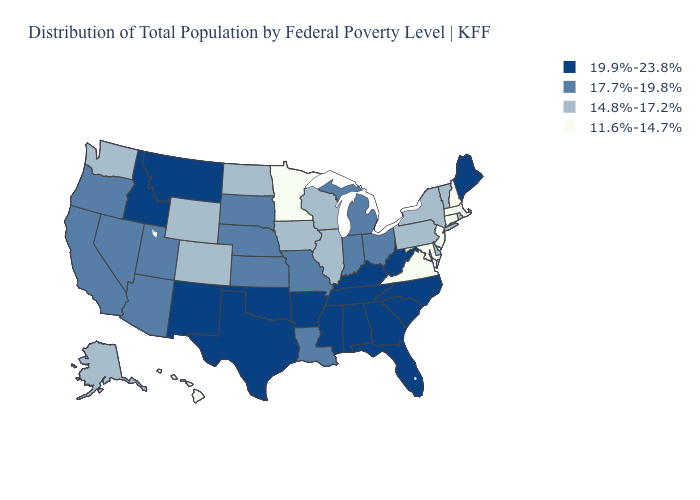What is the highest value in states that border Kansas?
Write a very short answer. 19.9%-23.8%. Name the states that have a value in the range 14.8%-17.2%?
Answer briefly. Alaska, Colorado, Delaware, Illinois, Iowa, New York, North Dakota, Pennsylvania, Rhode Island, Vermont, Washington, Wisconsin, Wyoming. Name the states that have a value in the range 19.9%-23.8%?
Be succinct. Alabama, Arkansas, Florida, Georgia, Idaho, Kentucky, Maine, Mississippi, Montana, New Mexico, North Carolina, Oklahoma, South Carolina, Tennessee, Texas, West Virginia. What is the value of Oklahoma?
Give a very brief answer. 19.9%-23.8%. Name the states that have a value in the range 19.9%-23.8%?
Answer briefly. Alabama, Arkansas, Florida, Georgia, Idaho, Kentucky, Maine, Mississippi, Montana, New Mexico, North Carolina, Oklahoma, South Carolina, Tennessee, Texas, West Virginia. What is the value of Kansas?
Write a very short answer. 17.7%-19.8%. What is the lowest value in the South?
Keep it brief. 11.6%-14.7%. Name the states that have a value in the range 17.7%-19.8%?
Be succinct. Arizona, California, Indiana, Kansas, Louisiana, Michigan, Missouri, Nebraska, Nevada, Ohio, Oregon, South Dakota, Utah. What is the value of Wisconsin?
Be succinct. 14.8%-17.2%. Name the states that have a value in the range 14.8%-17.2%?
Write a very short answer. Alaska, Colorado, Delaware, Illinois, Iowa, New York, North Dakota, Pennsylvania, Rhode Island, Vermont, Washington, Wisconsin, Wyoming. Among the states that border Pennsylvania , does New Jersey have the highest value?
Be succinct. No. What is the value of Kentucky?
Keep it brief. 19.9%-23.8%. Does Alabama have the highest value in the USA?
Short answer required. Yes. Does Hawaii have the lowest value in the West?
Short answer required. Yes. Name the states that have a value in the range 14.8%-17.2%?
Short answer required. Alaska, Colorado, Delaware, Illinois, Iowa, New York, North Dakota, Pennsylvania, Rhode Island, Vermont, Washington, Wisconsin, Wyoming. 